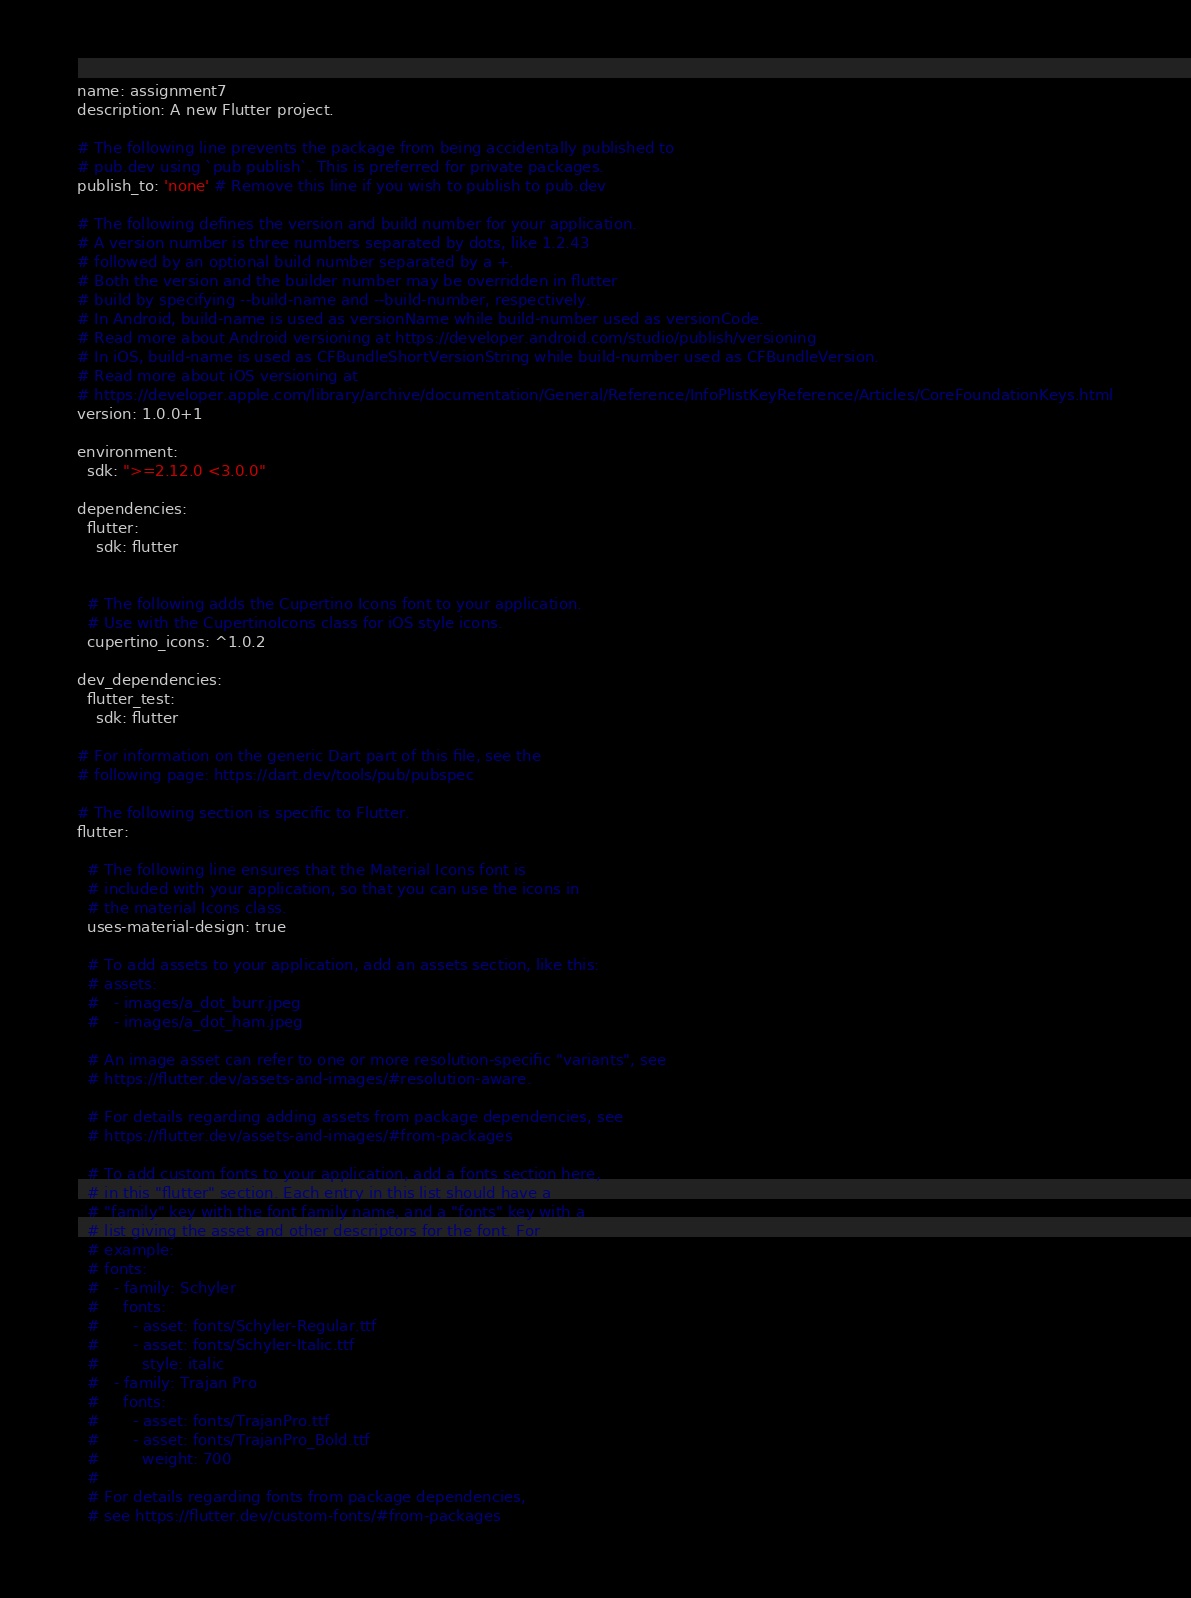<code> <loc_0><loc_0><loc_500><loc_500><_YAML_>name: assignment7
description: A new Flutter project.

# The following line prevents the package from being accidentally published to
# pub.dev using `pub publish`. This is preferred for private packages.
publish_to: 'none' # Remove this line if you wish to publish to pub.dev

# The following defines the version and build number for your application.
# A version number is three numbers separated by dots, like 1.2.43
# followed by an optional build number separated by a +.
# Both the version and the builder number may be overridden in flutter
# build by specifying --build-name and --build-number, respectively.
# In Android, build-name is used as versionName while build-number used as versionCode.
# Read more about Android versioning at https://developer.android.com/studio/publish/versioning
# In iOS, build-name is used as CFBundleShortVersionString while build-number used as CFBundleVersion.
# Read more about iOS versioning at
# https://developer.apple.com/library/archive/documentation/General/Reference/InfoPlistKeyReference/Articles/CoreFoundationKeys.html
version: 1.0.0+1

environment:
  sdk: ">=2.12.0 <3.0.0"

dependencies:
  flutter:
    sdk: flutter


  # The following adds the Cupertino Icons font to your application.
  # Use with the CupertinoIcons class for iOS style icons.
  cupertino_icons: ^1.0.2

dev_dependencies:
  flutter_test:
    sdk: flutter

# For information on the generic Dart part of this file, see the
# following page: https://dart.dev/tools/pub/pubspec

# The following section is specific to Flutter.
flutter:

  # The following line ensures that the Material Icons font is
  # included with your application, so that you can use the icons in
  # the material Icons class.
  uses-material-design: true

  # To add assets to your application, add an assets section, like this:
  # assets:
  #   - images/a_dot_burr.jpeg
  #   - images/a_dot_ham.jpeg

  # An image asset can refer to one or more resolution-specific "variants", see
  # https://flutter.dev/assets-and-images/#resolution-aware.

  # For details regarding adding assets from package dependencies, see
  # https://flutter.dev/assets-and-images/#from-packages

  # To add custom fonts to your application, add a fonts section here,
  # in this "flutter" section. Each entry in this list should have a
  # "family" key with the font family name, and a "fonts" key with a
  # list giving the asset and other descriptors for the font. For
  # example:
  # fonts:
  #   - family: Schyler
  #     fonts:
  #       - asset: fonts/Schyler-Regular.ttf
  #       - asset: fonts/Schyler-Italic.ttf
  #         style: italic
  #   - family: Trajan Pro
  #     fonts:
  #       - asset: fonts/TrajanPro.ttf
  #       - asset: fonts/TrajanPro_Bold.ttf
  #         weight: 700
  #
  # For details regarding fonts from package dependencies,
  # see https://flutter.dev/custom-fonts/#from-packages
</code> 